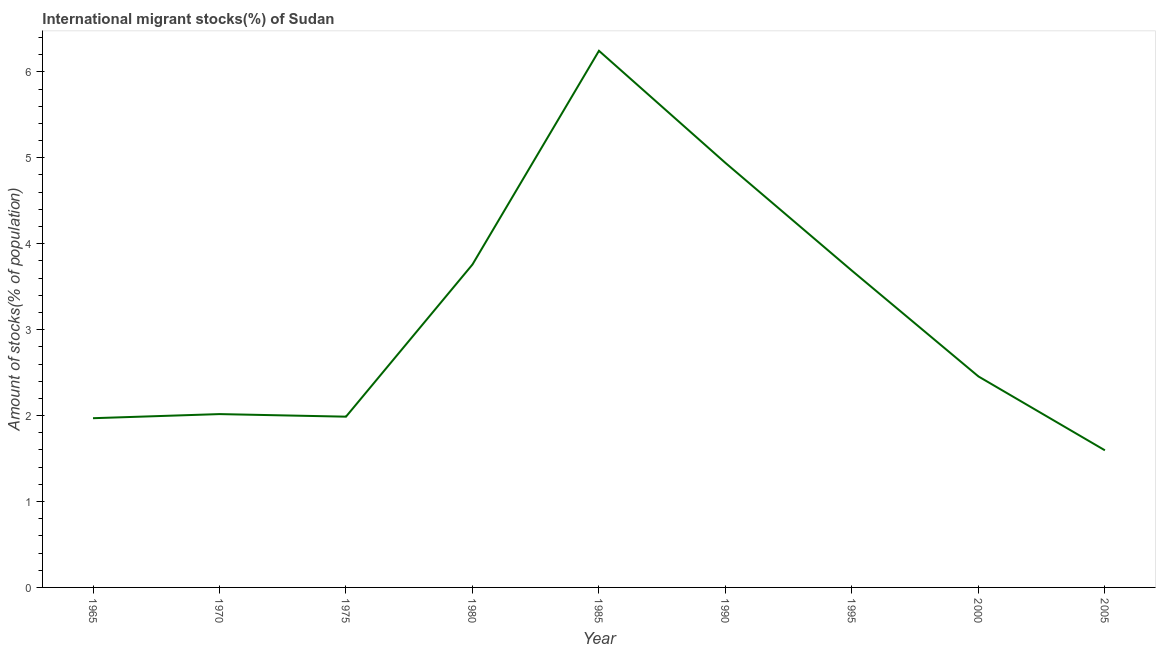What is the number of international migrant stocks in 1970?
Your answer should be very brief. 2.02. Across all years, what is the maximum number of international migrant stocks?
Provide a succinct answer. 6.24. Across all years, what is the minimum number of international migrant stocks?
Make the answer very short. 1.6. In which year was the number of international migrant stocks maximum?
Offer a very short reply. 1985. What is the sum of the number of international migrant stocks?
Provide a short and direct response. 28.65. What is the difference between the number of international migrant stocks in 1970 and 1995?
Make the answer very short. -1.67. What is the average number of international migrant stocks per year?
Provide a succinct answer. 3.18. What is the median number of international migrant stocks?
Offer a very short reply. 2.46. What is the ratio of the number of international migrant stocks in 1970 to that in 2005?
Make the answer very short. 1.26. Is the number of international migrant stocks in 1985 less than that in 1990?
Give a very brief answer. No. What is the difference between the highest and the second highest number of international migrant stocks?
Ensure brevity in your answer.  1.3. What is the difference between the highest and the lowest number of international migrant stocks?
Provide a succinct answer. 4.65. In how many years, is the number of international migrant stocks greater than the average number of international migrant stocks taken over all years?
Offer a very short reply. 4. Are the values on the major ticks of Y-axis written in scientific E-notation?
Give a very brief answer. No. Does the graph contain any zero values?
Keep it short and to the point. No. What is the title of the graph?
Give a very brief answer. International migrant stocks(%) of Sudan. What is the label or title of the X-axis?
Give a very brief answer. Year. What is the label or title of the Y-axis?
Your answer should be compact. Amount of stocks(% of population). What is the Amount of stocks(% of population) in 1965?
Provide a short and direct response. 1.97. What is the Amount of stocks(% of population) in 1970?
Offer a very short reply. 2.02. What is the Amount of stocks(% of population) of 1975?
Provide a short and direct response. 1.99. What is the Amount of stocks(% of population) in 1980?
Provide a short and direct response. 3.76. What is the Amount of stocks(% of population) of 1985?
Your response must be concise. 6.24. What is the Amount of stocks(% of population) of 1990?
Make the answer very short. 4.94. What is the Amount of stocks(% of population) in 1995?
Give a very brief answer. 3.69. What is the Amount of stocks(% of population) in 2000?
Make the answer very short. 2.46. What is the Amount of stocks(% of population) in 2005?
Provide a succinct answer. 1.6. What is the difference between the Amount of stocks(% of population) in 1965 and 1970?
Make the answer very short. -0.05. What is the difference between the Amount of stocks(% of population) in 1965 and 1975?
Ensure brevity in your answer.  -0.02. What is the difference between the Amount of stocks(% of population) in 1965 and 1980?
Make the answer very short. -1.79. What is the difference between the Amount of stocks(% of population) in 1965 and 1985?
Ensure brevity in your answer.  -4.28. What is the difference between the Amount of stocks(% of population) in 1965 and 1990?
Provide a short and direct response. -2.97. What is the difference between the Amount of stocks(% of population) in 1965 and 1995?
Your response must be concise. -1.72. What is the difference between the Amount of stocks(% of population) in 1965 and 2000?
Your answer should be very brief. -0.49. What is the difference between the Amount of stocks(% of population) in 1965 and 2005?
Your answer should be compact. 0.37. What is the difference between the Amount of stocks(% of population) in 1970 and 1975?
Provide a succinct answer. 0.03. What is the difference between the Amount of stocks(% of population) in 1970 and 1980?
Provide a short and direct response. -1.74. What is the difference between the Amount of stocks(% of population) in 1970 and 1985?
Your answer should be compact. -4.23. What is the difference between the Amount of stocks(% of population) in 1970 and 1990?
Provide a short and direct response. -2.92. What is the difference between the Amount of stocks(% of population) in 1970 and 1995?
Your response must be concise. -1.67. What is the difference between the Amount of stocks(% of population) in 1970 and 2000?
Offer a terse response. -0.44. What is the difference between the Amount of stocks(% of population) in 1970 and 2005?
Your answer should be compact. 0.42. What is the difference between the Amount of stocks(% of population) in 1975 and 1980?
Your answer should be very brief. -1.77. What is the difference between the Amount of stocks(% of population) in 1975 and 1985?
Your answer should be very brief. -4.26. What is the difference between the Amount of stocks(% of population) in 1975 and 1990?
Your answer should be compact. -2.95. What is the difference between the Amount of stocks(% of population) in 1975 and 1995?
Give a very brief answer. -1.7. What is the difference between the Amount of stocks(% of population) in 1975 and 2000?
Provide a short and direct response. -0.47. What is the difference between the Amount of stocks(% of population) in 1975 and 2005?
Keep it short and to the point. 0.39. What is the difference between the Amount of stocks(% of population) in 1980 and 1985?
Provide a succinct answer. -2.49. What is the difference between the Amount of stocks(% of population) in 1980 and 1990?
Your answer should be very brief. -1.18. What is the difference between the Amount of stocks(% of population) in 1980 and 1995?
Your response must be concise. 0.07. What is the difference between the Amount of stocks(% of population) in 1980 and 2000?
Give a very brief answer. 1.3. What is the difference between the Amount of stocks(% of population) in 1980 and 2005?
Your answer should be compact. 2.16. What is the difference between the Amount of stocks(% of population) in 1985 and 1990?
Keep it short and to the point. 1.3. What is the difference between the Amount of stocks(% of population) in 1985 and 1995?
Offer a terse response. 2.56. What is the difference between the Amount of stocks(% of population) in 1985 and 2000?
Make the answer very short. 3.79. What is the difference between the Amount of stocks(% of population) in 1985 and 2005?
Make the answer very short. 4.65. What is the difference between the Amount of stocks(% of population) in 1990 and 1995?
Give a very brief answer. 1.25. What is the difference between the Amount of stocks(% of population) in 1990 and 2000?
Make the answer very short. 2.48. What is the difference between the Amount of stocks(% of population) in 1990 and 2005?
Provide a succinct answer. 3.34. What is the difference between the Amount of stocks(% of population) in 1995 and 2000?
Ensure brevity in your answer.  1.23. What is the difference between the Amount of stocks(% of population) in 1995 and 2005?
Your response must be concise. 2.09. What is the difference between the Amount of stocks(% of population) in 2000 and 2005?
Keep it short and to the point. 0.86. What is the ratio of the Amount of stocks(% of population) in 1965 to that in 1970?
Offer a terse response. 0.98. What is the ratio of the Amount of stocks(% of population) in 1965 to that in 1975?
Make the answer very short. 0.99. What is the ratio of the Amount of stocks(% of population) in 1965 to that in 1980?
Your answer should be very brief. 0.52. What is the ratio of the Amount of stocks(% of population) in 1965 to that in 1985?
Your answer should be very brief. 0.32. What is the ratio of the Amount of stocks(% of population) in 1965 to that in 1990?
Your answer should be very brief. 0.4. What is the ratio of the Amount of stocks(% of population) in 1965 to that in 1995?
Your answer should be very brief. 0.53. What is the ratio of the Amount of stocks(% of population) in 1965 to that in 2000?
Provide a short and direct response. 0.8. What is the ratio of the Amount of stocks(% of population) in 1965 to that in 2005?
Ensure brevity in your answer.  1.23. What is the ratio of the Amount of stocks(% of population) in 1970 to that in 1980?
Provide a short and direct response. 0.54. What is the ratio of the Amount of stocks(% of population) in 1970 to that in 1985?
Your response must be concise. 0.32. What is the ratio of the Amount of stocks(% of population) in 1970 to that in 1990?
Offer a terse response. 0.41. What is the ratio of the Amount of stocks(% of population) in 1970 to that in 1995?
Your response must be concise. 0.55. What is the ratio of the Amount of stocks(% of population) in 1970 to that in 2000?
Keep it short and to the point. 0.82. What is the ratio of the Amount of stocks(% of population) in 1970 to that in 2005?
Make the answer very short. 1.26. What is the ratio of the Amount of stocks(% of population) in 1975 to that in 1980?
Provide a short and direct response. 0.53. What is the ratio of the Amount of stocks(% of population) in 1975 to that in 1985?
Your response must be concise. 0.32. What is the ratio of the Amount of stocks(% of population) in 1975 to that in 1990?
Give a very brief answer. 0.4. What is the ratio of the Amount of stocks(% of population) in 1975 to that in 1995?
Your answer should be very brief. 0.54. What is the ratio of the Amount of stocks(% of population) in 1975 to that in 2000?
Make the answer very short. 0.81. What is the ratio of the Amount of stocks(% of population) in 1975 to that in 2005?
Your response must be concise. 1.25. What is the ratio of the Amount of stocks(% of population) in 1980 to that in 1985?
Your answer should be compact. 0.6. What is the ratio of the Amount of stocks(% of population) in 1980 to that in 1990?
Your response must be concise. 0.76. What is the ratio of the Amount of stocks(% of population) in 1980 to that in 1995?
Your response must be concise. 1.02. What is the ratio of the Amount of stocks(% of population) in 1980 to that in 2000?
Offer a terse response. 1.53. What is the ratio of the Amount of stocks(% of population) in 1980 to that in 2005?
Give a very brief answer. 2.35. What is the ratio of the Amount of stocks(% of population) in 1985 to that in 1990?
Provide a short and direct response. 1.26. What is the ratio of the Amount of stocks(% of population) in 1985 to that in 1995?
Offer a very short reply. 1.69. What is the ratio of the Amount of stocks(% of population) in 1985 to that in 2000?
Provide a short and direct response. 2.54. What is the ratio of the Amount of stocks(% of population) in 1985 to that in 2005?
Offer a terse response. 3.91. What is the ratio of the Amount of stocks(% of population) in 1990 to that in 1995?
Make the answer very short. 1.34. What is the ratio of the Amount of stocks(% of population) in 1990 to that in 2000?
Make the answer very short. 2.01. What is the ratio of the Amount of stocks(% of population) in 1990 to that in 2005?
Ensure brevity in your answer.  3.1. What is the ratio of the Amount of stocks(% of population) in 1995 to that in 2000?
Your answer should be compact. 1.5. What is the ratio of the Amount of stocks(% of population) in 1995 to that in 2005?
Your answer should be very brief. 2.31. What is the ratio of the Amount of stocks(% of population) in 2000 to that in 2005?
Your answer should be very brief. 1.54. 